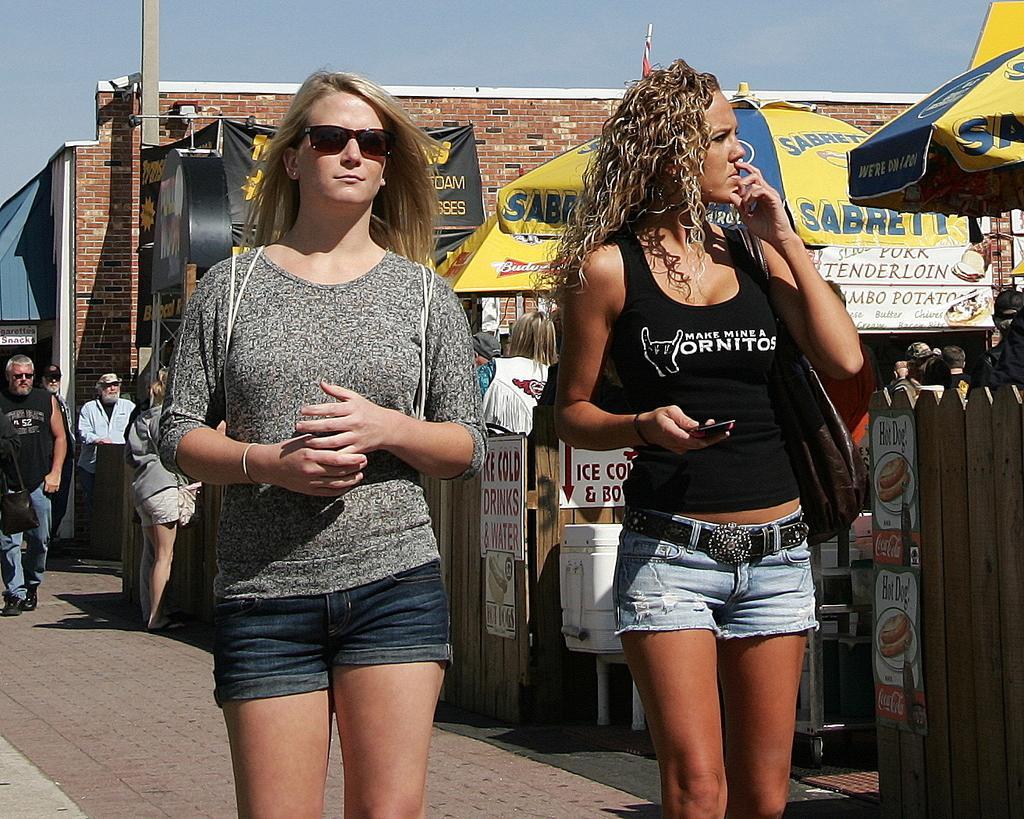Can you describe this image briefly? In this picture there are two women standing and there are few umbrellas,stores and some other people behind them. 